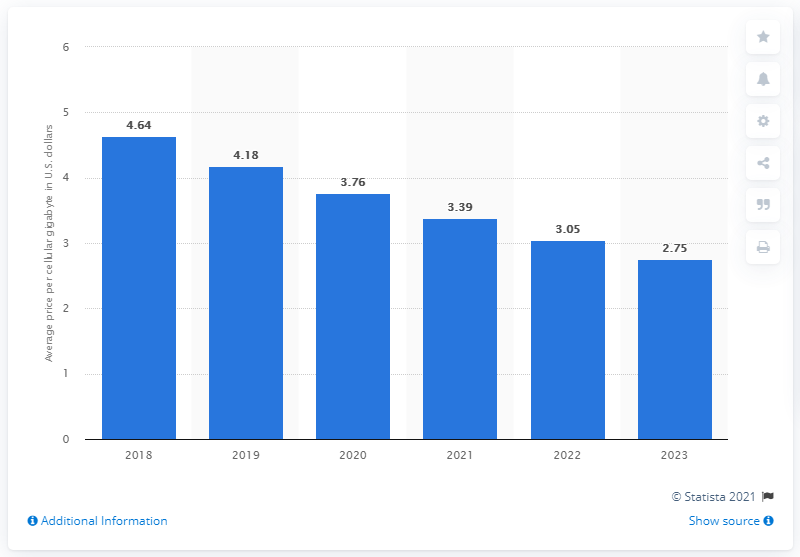Specify some key components in this picture. In 2018, the average price of cellular data per gigabyte (GB) was $4.64 in dollars. The average price of cellular data in the U.S. is projected to end in 2023. 